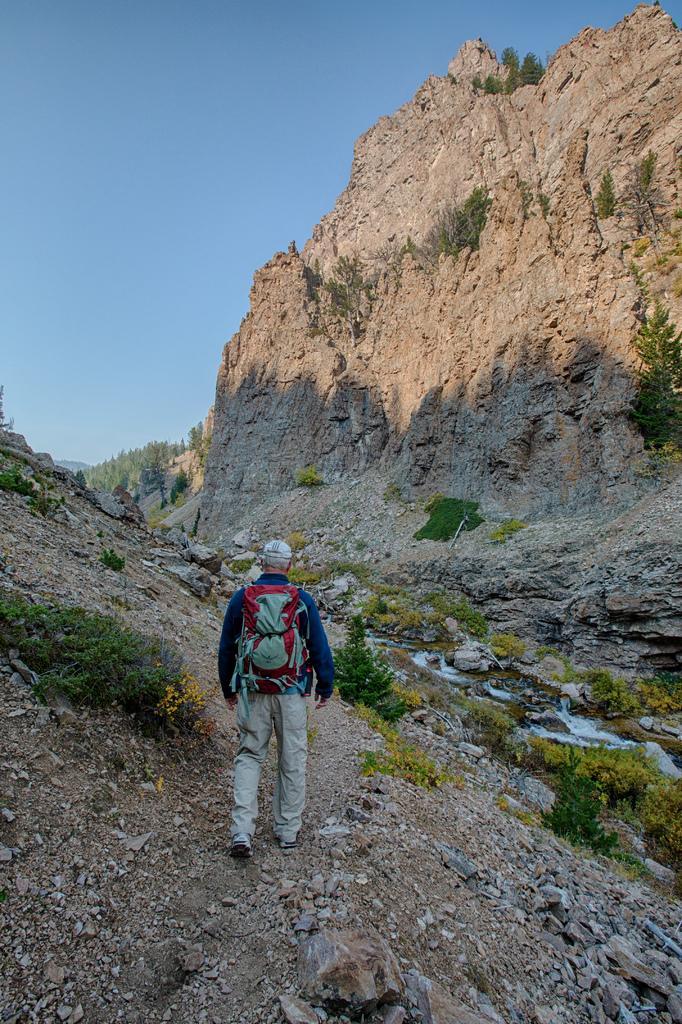Describe this image in one or two sentences. In this image there is a person standing at bottom of this image is holding a backpack and there are some plants in middle of this image, and there is a mountain at top of this image and there is a sky in the background. 